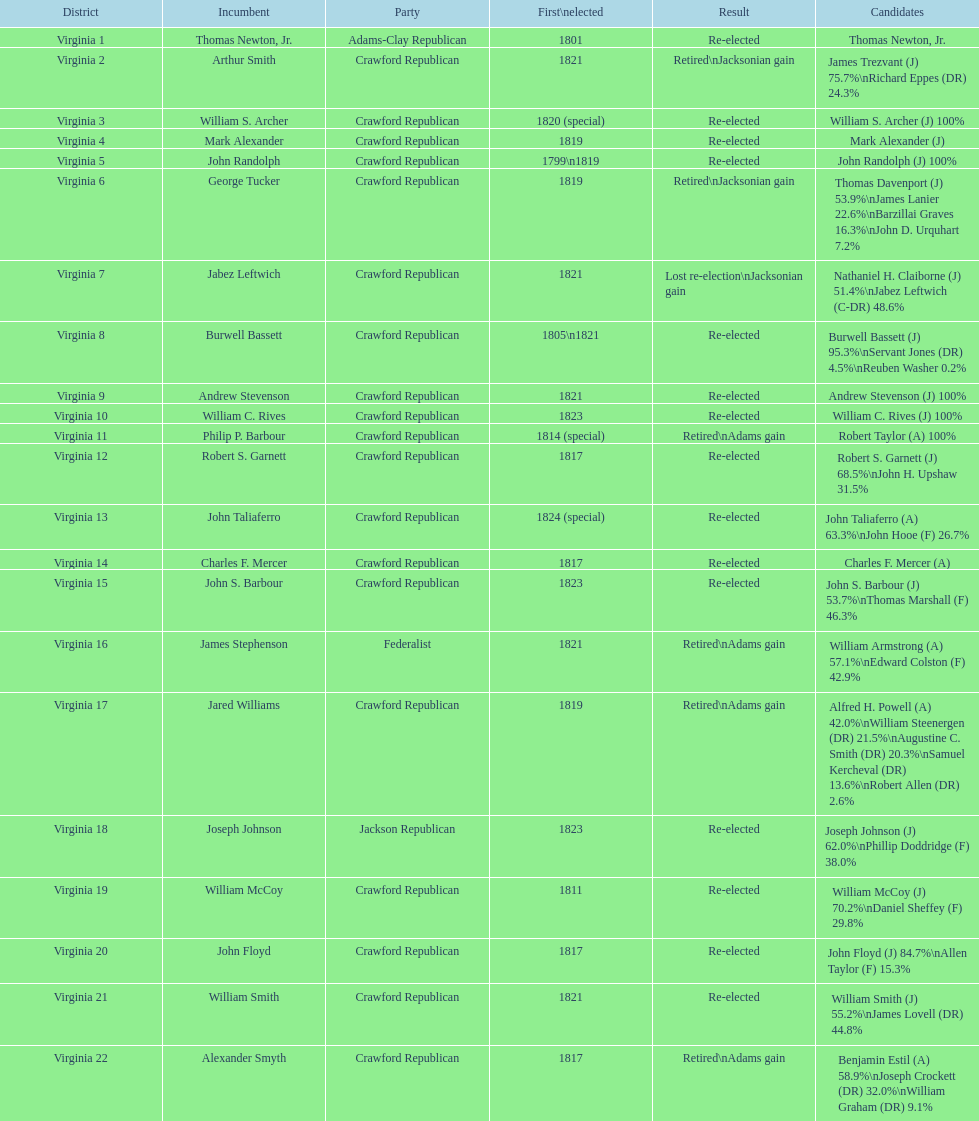What is the concluding party on this chart? Crawford Republican. 